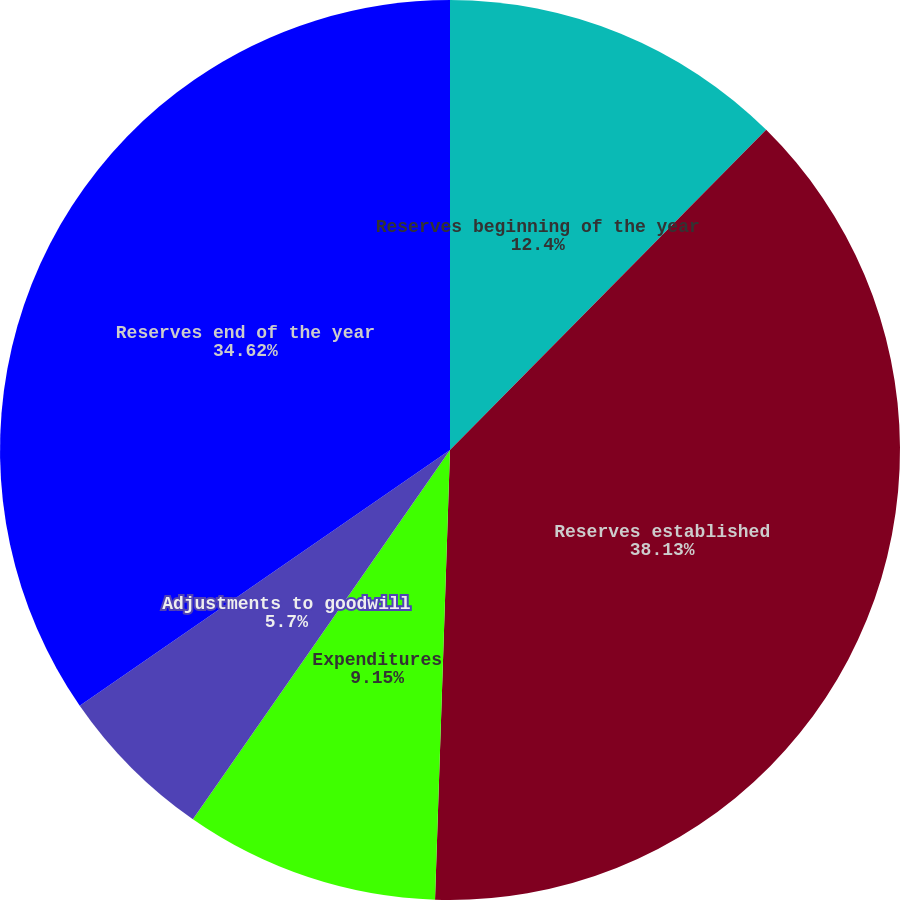<chart> <loc_0><loc_0><loc_500><loc_500><pie_chart><fcel>Reserves beginning of the year<fcel>Reserves established<fcel>Expenditures<fcel>Adjustments to goodwill<fcel>Reserves end of the year<nl><fcel>12.4%<fcel>38.13%<fcel>9.15%<fcel>5.7%<fcel>34.62%<nl></chart> 